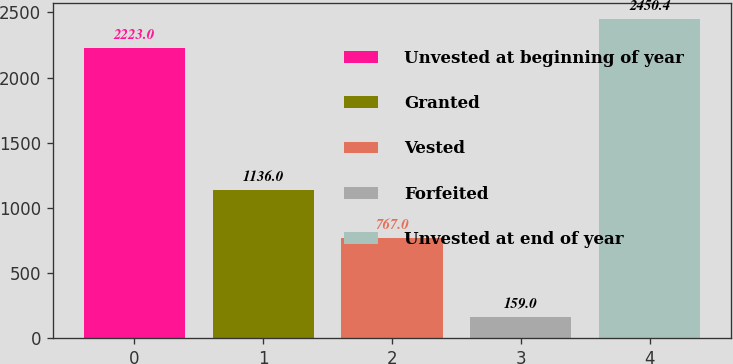<chart> <loc_0><loc_0><loc_500><loc_500><bar_chart><fcel>Unvested at beginning of year<fcel>Granted<fcel>Vested<fcel>Forfeited<fcel>Unvested at end of year<nl><fcel>2223<fcel>1136<fcel>767<fcel>159<fcel>2450.4<nl></chart> 